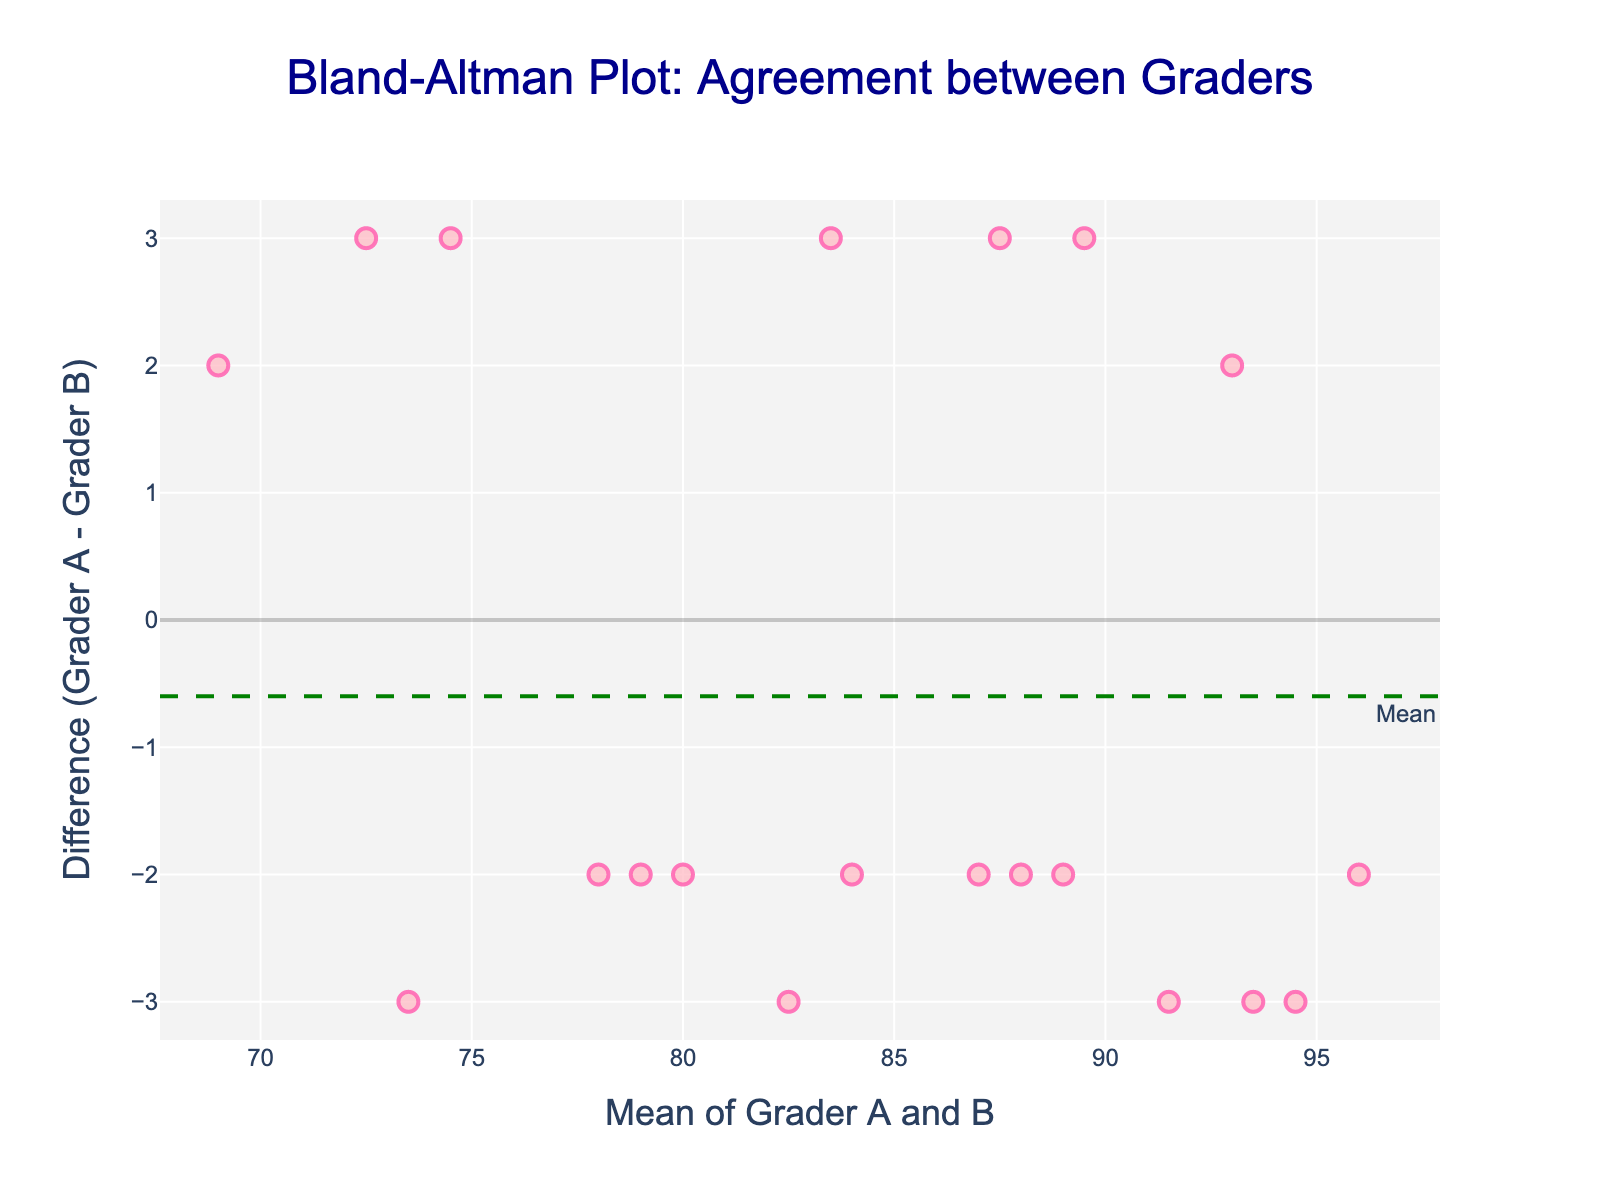What is the title of the plot? The title is always at the top of the plot, prominently displayed for easy identification. It reads: "Bland-Altman Plot: Agreement between Graders".
Answer: Bland-Altman Plot: Agreement between Graders What does the x-axis represent? The label of the x-axis can be read directly from the plot. It states: "Mean of Grader A and B".
Answer: Mean of Grader A and B How many data points are scattered on the plot? Each data point corresponds to a pair of grades from Grader_A and Grader_B. Counting the total number of points on the plot will give the answer. There are 20 points for 20 pairs of grades.
Answer: 20 What are the colors used for the scatter points? The scatter points are visually recognizable by their specific color pattern. They are pink with a darker pink outline.
Answer: Pink with a darker pink outline What is the approximate value of the mean difference line? The mean difference line is marked by a dashed green line on the plot. Reading the y-coordinate where this line is placed gives its value, which is around -0.2.
Answer: -0.2 What are the values for the limits of agreement lines? The limits of agreement lines, marked by red dotted lines, are labeled as "+1.96 SD" and "-1.96 SD". The approximate values where these lines are placed are, respectively, around 6.0 for the upper limit and around -6.4 for the lower limit.
Answer: 6.0 and -6.4 Which graders tend to give higher scores, Grader A or Grader B? To determine this, observe if the differences (Grader A - Grader B) are mostly positive or negative. Since the differences are generally close to zero and evenly distributed around the mean difference line with slight negative skew, Grader B tends to give slightly higher scores, but the difference is marginal.
Answer: Grader B What is the range of the y-axis? Looking at the y-axis, we can see the range extends approximately from -8 to +8.
Answer: -8 to +8 Are there any outliers visible in the differences? An outlier in the context of a Bland-Altman plot is a point that falls significantly outside the limits of agreement lines. Observing the plot, we see that no points fall outside these lines; thus, there are no obvious outliers.
Answer: No 